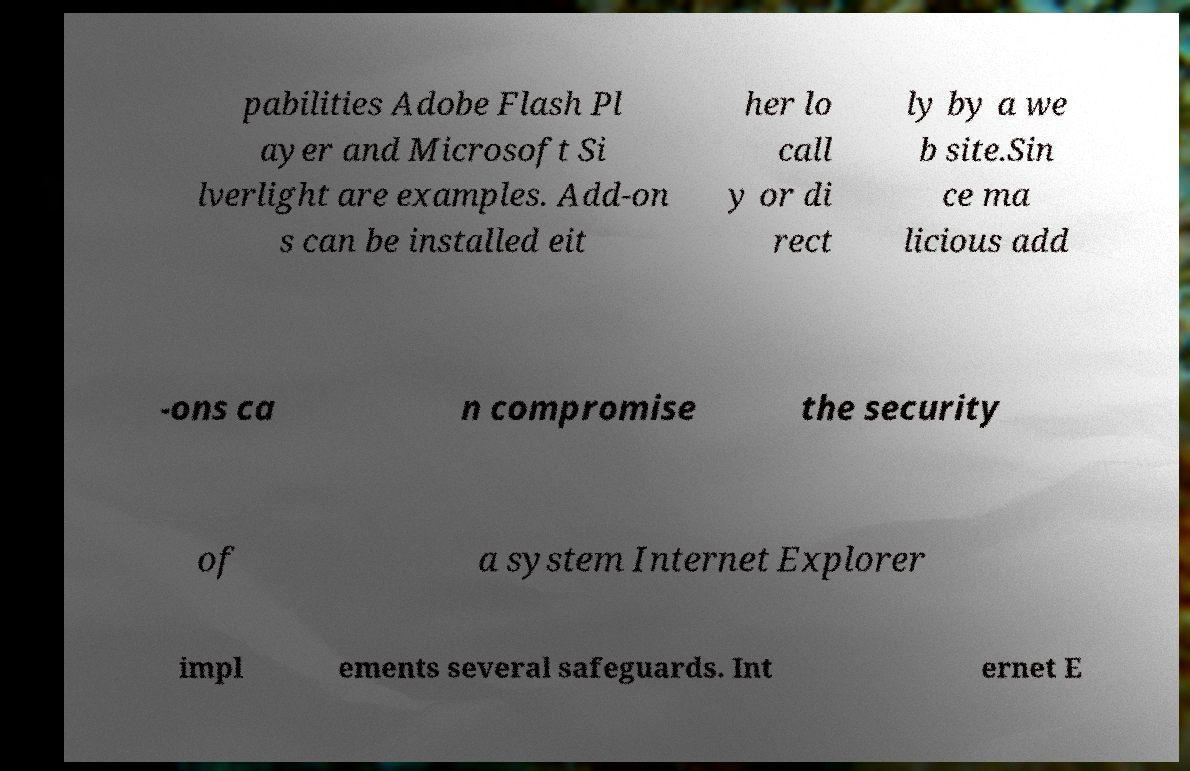I need the written content from this picture converted into text. Can you do that? pabilities Adobe Flash Pl ayer and Microsoft Si lverlight are examples. Add-on s can be installed eit her lo call y or di rect ly by a we b site.Sin ce ma licious add -ons ca n compromise the security of a system Internet Explorer impl ements several safeguards. Int ernet E 